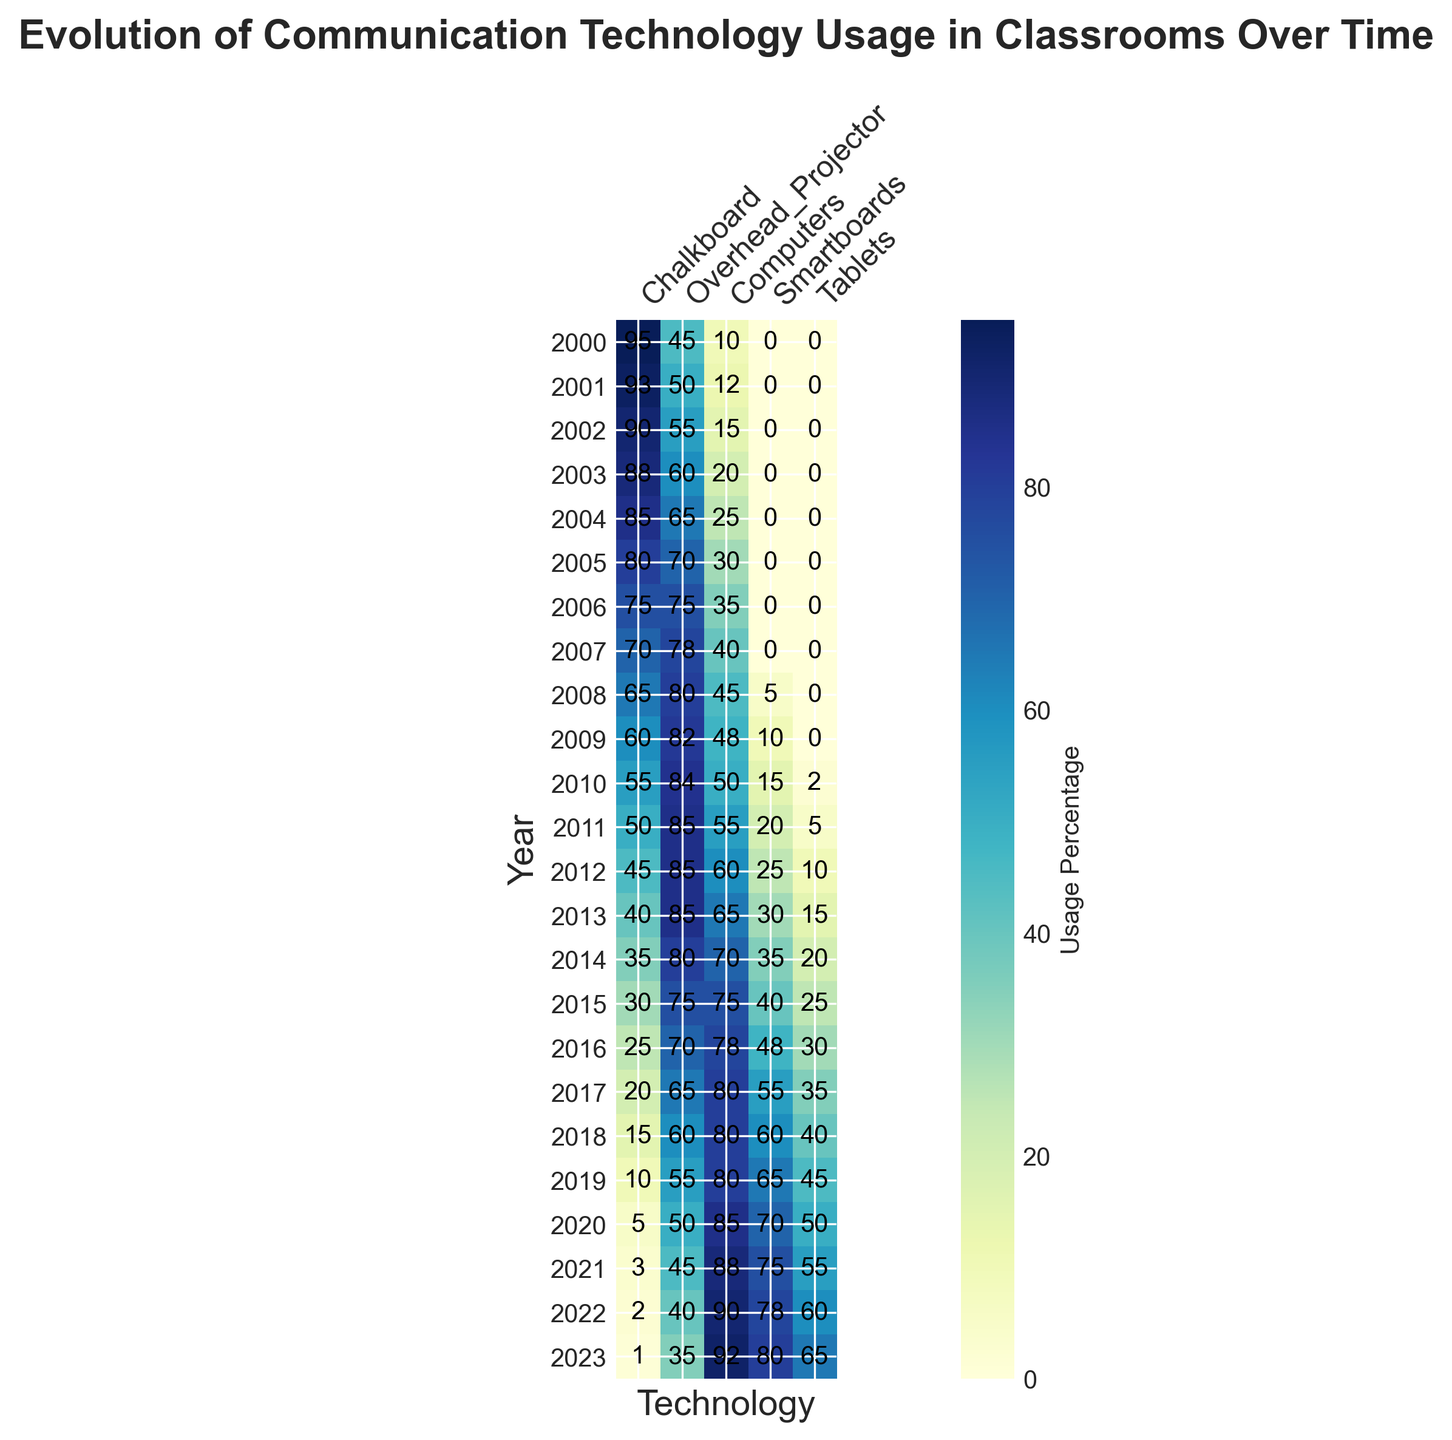What technology had the highest usage percentage in classrooms in 2000? Look at the row corresponding to the year 2000. The highest usage percentage is for "Chalkboard" at 95%.
Answer: Chalkboard How did the usage of Smartboards change from 2008 to 2023? Compare the value for Smartboards in 2008 (5) with the value in 2023 (80). The usage increased by 75 percentage points.
Answer: Increased by 75 percentage points Which technology had a consistent increase in usage from 2000 to 2023? Skim across all rows to identify which technology had a steady increase in values from 2000 to 2023. "Computers" consistently increased from 10 to 92.
Answer: Computers What is the average usage percentage of Tablets over all years? Add up the usage percentages of Tablets for each year and divide by the number of years (24). (0+0+...+65)/24 = 16.25.
Answer: 16.25 In which year was the chalkboard usage equal to the overhead projector usage? Find the year(s) where the values for Chalkboard and Overhead_Projector are the same. This happens in 2021, both at 3.
Answer: 2021 What is the difference in engagement score between the years 2000 and 2023? Subtract the engagement score of 2000 (60) from that of 2023 (93), so 93 - 60 = 33.
Answer: 33 Which technology's usage experienced the biggest increase from one year to the next? Compute the yearly differences in usage for each technology and find the maximum value. The biggest increase is for Computers from 2019 (80) to 2020 (85), an increase of 5.
Answer: Computers (from 2019 to 2020) How does the color intensity for Computers compare between 2010 and 2015? Visual comparison of the color intensity shows darker shades for Computers in 2015 as compared to 2010, indicating higher usage in 2015.
Answer: Darker in 2015 Is there a correlation between the usage of Tablets and the overall engagement score? Observe the trend for Tablets and Engagement_Score over the years. As Tablet usage increases (noticeably from 2010 onwards), the Engagement_Score also shows a consistent increase.
Answer: Yes 